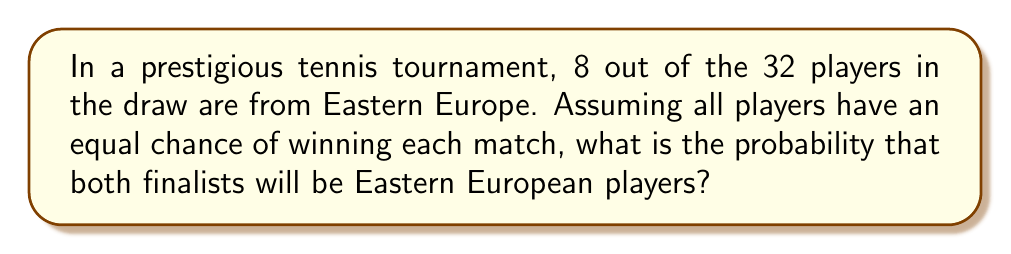Can you solve this math problem? Let's approach this step-by-step:

1) First, we need to calculate the probability of an Eastern European player reaching the final. This can be done by considering the opposite event - the probability that no Eastern European player reaches the final.

2) The probability of a non-Eastern European player winning a match against an Eastern European player is:

   $P(\text{non-EE wins}) = \frac{24}{32} = \frac{3}{4}$

3) For no Eastern European player to reach the final, this needs to happen in all matches involving Eastern European players. The number of such matches is 8 (since there are 8 Eastern European players).

4) Therefore, the probability of no Eastern European player reaching the final is:

   $P(\text{no EE in final}) = (\frac{3}{4})^8 = \frac{6561}{65536}$

5) The probability of at least one Eastern European player reaching the final is the complement of this:

   $P(\text{at least one EE in final}) = 1 - \frac{6561}{65536} = \frac{58975}{65536}$

6) For both finalists to be Eastern European, this needs to happen independently for both finalist positions. So we square the probability:

   $P(\text{both finalists EE}) = (\frac{58975}{65536})^2 = \frac{3478006015625}{4294967296}$

7) This can be simplified to:

   $P(\text{both finalists EE}) = \frac{3478006015625}{4294967296} \approx 0.8099$ or about 80.99%
Answer: $\frac{3478006015625}{4294967296}$ or approximately 80.99% 